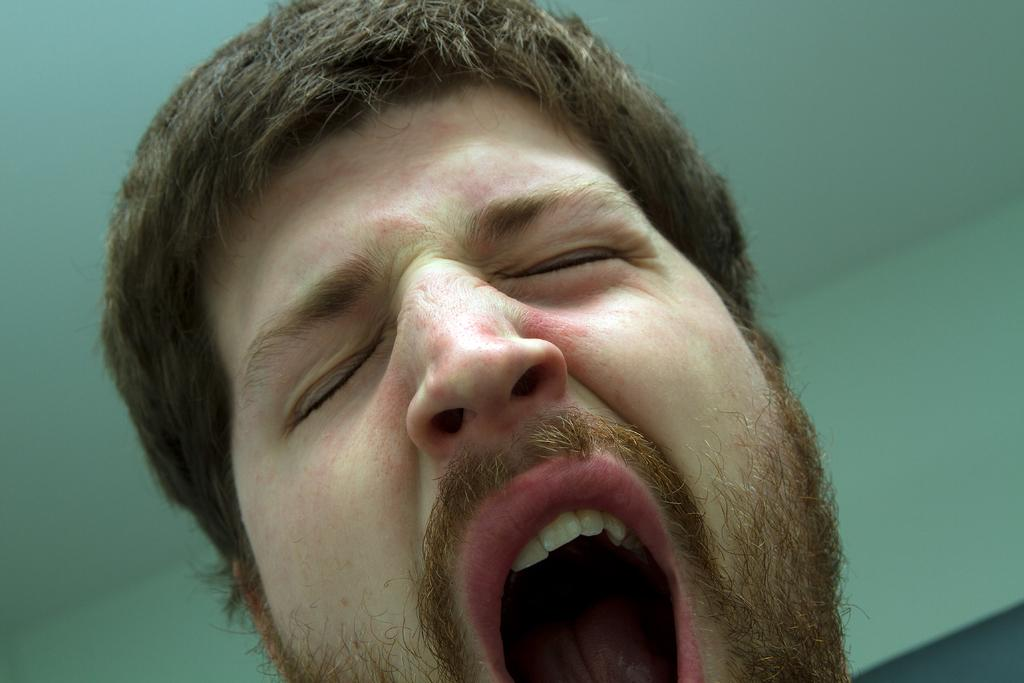What is the main subject of the image? There is a man in the image. What is the man doing in the image? The man is yawning. What can be seen in the background of the image? There is a wall in the background of the image. What type of snow can be seen falling in the image? There is no snow present in the image; it features a man yawning with a wall in the background. What is the man using to press the thumb in the image? There is no thumb or pressing action depicted in the image. 